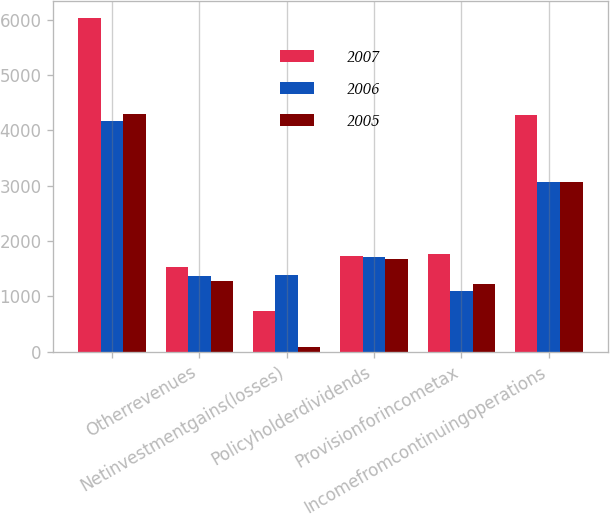<chart> <loc_0><loc_0><loc_500><loc_500><stacked_bar_chart><ecel><fcel>Unnamed: 1<fcel>Otherrevenues<fcel>Netinvestmentgains(losses)<fcel>Policyholderdividends<fcel>Provisionforincometax<fcel>Incomefromcontinuingoperations<nl><fcel>2007<fcel>6039<fcel>1533<fcel>738<fcel>1726<fcel>1759<fcel>4280<nl><fcel>2006<fcel>4168<fcel>1362<fcel>1382<fcel>1701<fcel>1097<fcel>3071<nl><fcel>2005<fcel>4293<fcel>1271<fcel>86<fcel>1679<fcel>1222<fcel>3071<nl></chart> 